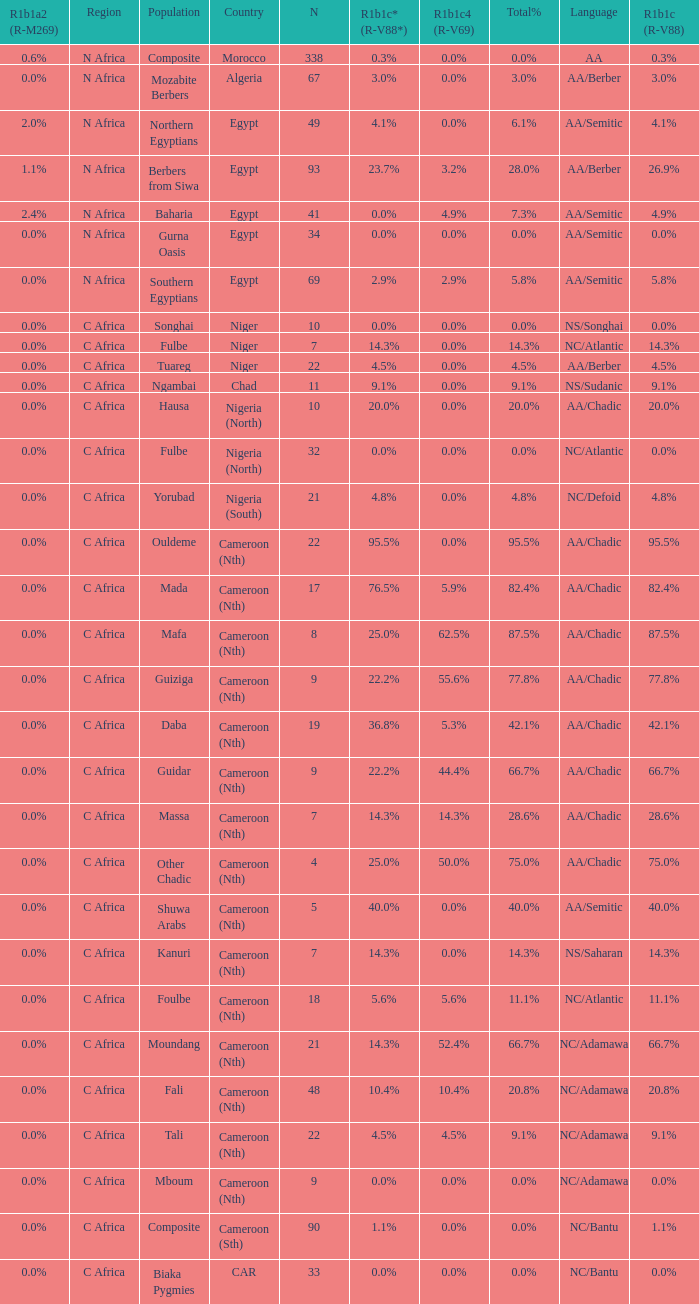How many n are listed for 0.6% r1b1a2 (r-m269)? 1.0. 